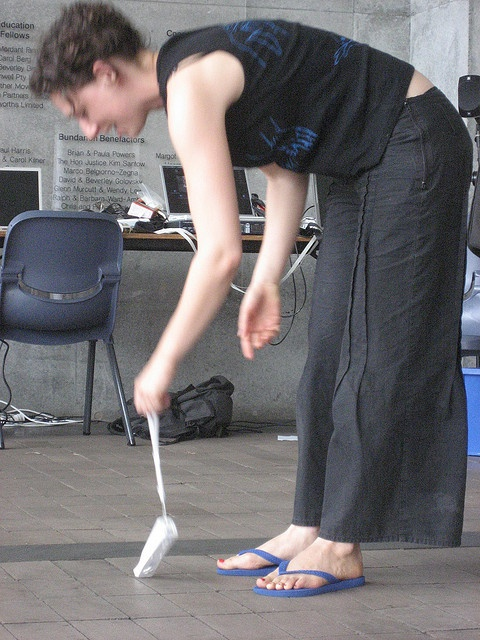Describe the objects in this image and their specific colors. I can see people in darkgray, black, gray, and white tones, chair in darkgray, gray, black, and darkblue tones, backpack in darkgray, black, gray, and purple tones, laptop in darkgray, black, gray, and lightgray tones, and laptop in darkgray, black, and lightgray tones in this image. 